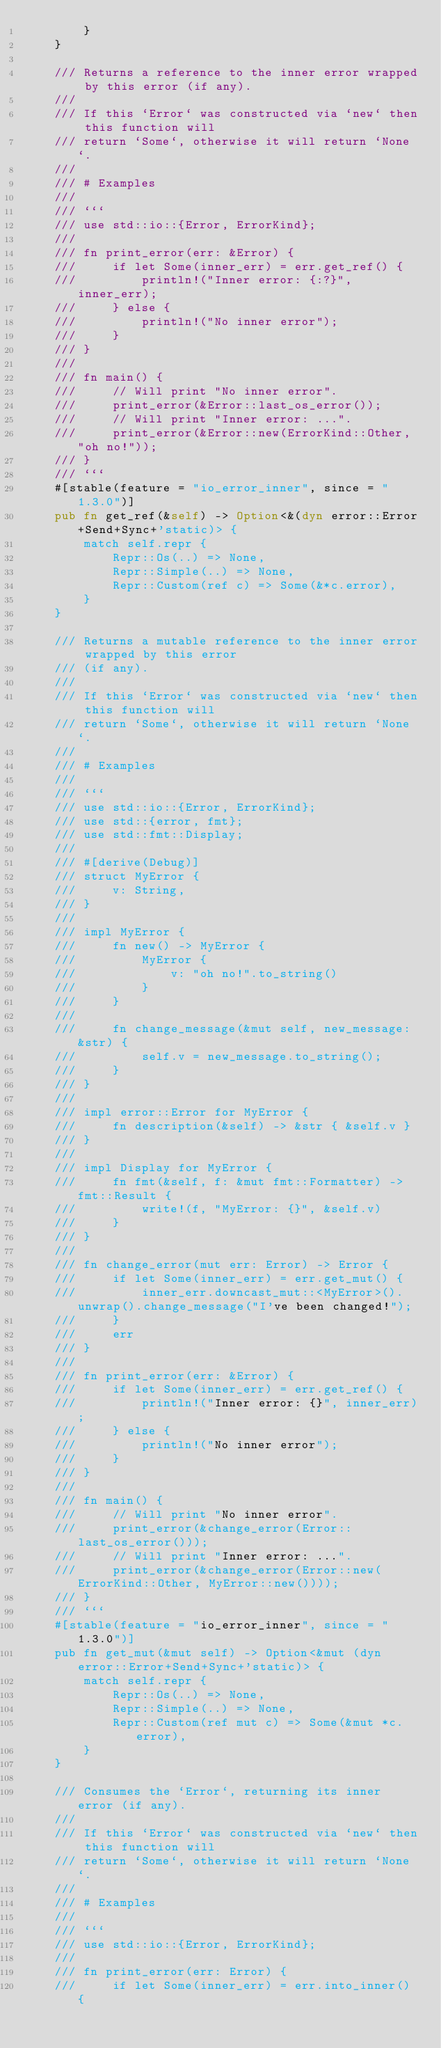<code> <loc_0><loc_0><loc_500><loc_500><_Rust_>        }
    }

    /// Returns a reference to the inner error wrapped by this error (if any).
    ///
    /// If this `Error` was constructed via `new` then this function will
    /// return `Some`, otherwise it will return `None`.
    ///
    /// # Examples
    ///
    /// ```
    /// use std::io::{Error, ErrorKind};
    ///
    /// fn print_error(err: &Error) {
    ///     if let Some(inner_err) = err.get_ref() {
    ///         println!("Inner error: {:?}", inner_err);
    ///     } else {
    ///         println!("No inner error");
    ///     }
    /// }
    ///
    /// fn main() {
    ///     // Will print "No inner error".
    ///     print_error(&Error::last_os_error());
    ///     // Will print "Inner error: ...".
    ///     print_error(&Error::new(ErrorKind::Other, "oh no!"));
    /// }
    /// ```
    #[stable(feature = "io_error_inner", since = "1.3.0")]
    pub fn get_ref(&self) -> Option<&(dyn error::Error+Send+Sync+'static)> {
        match self.repr {
            Repr::Os(..) => None,
            Repr::Simple(..) => None,
            Repr::Custom(ref c) => Some(&*c.error),
        }
    }

    /// Returns a mutable reference to the inner error wrapped by this error
    /// (if any).
    ///
    /// If this `Error` was constructed via `new` then this function will
    /// return `Some`, otherwise it will return `None`.
    ///
    /// # Examples
    ///
    /// ```
    /// use std::io::{Error, ErrorKind};
    /// use std::{error, fmt};
    /// use std::fmt::Display;
    ///
    /// #[derive(Debug)]
    /// struct MyError {
    ///     v: String,
    /// }
    ///
    /// impl MyError {
    ///     fn new() -> MyError {
    ///         MyError {
    ///             v: "oh no!".to_string()
    ///         }
    ///     }
    ///
    ///     fn change_message(&mut self, new_message: &str) {
    ///         self.v = new_message.to_string();
    ///     }
    /// }
    ///
    /// impl error::Error for MyError {
    ///     fn description(&self) -> &str { &self.v }
    /// }
    ///
    /// impl Display for MyError {
    ///     fn fmt(&self, f: &mut fmt::Formatter) -> fmt::Result {
    ///         write!(f, "MyError: {}", &self.v)
    ///     }
    /// }
    ///
    /// fn change_error(mut err: Error) -> Error {
    ///     if let Some(inner_err) = err.get_mut() {
    ///         inner_err.downcast_mut::<MyError>().unwrap().change_message("I've been changed!");
    ///     }
    ///     err
    /// }
    ///
    /// fn print_error(err: &Error) {
    ///     if let Some(inner_err) = err.get_ref() {
    ///         println!("Inner error: {}", inner_err);
    ///     } else {
    ///         println!("No inner error");
    ///     }
    /// }
    ///
    /// fn main() {
    ///     // Will print "No inner error".
    ///     print_error(&change_error(Error::last_os_error()));
    ///     // Will print "Inner error: ...".
    ///     print_error(&change_error(Error::new(ErrorKind::Other, MyError::new())));
    /// }
    /// ```
    #[stable(feature = "io_error_inner", since = "1.3.0")]
    pub fn get_mut(&mut self) -> Option<&mut (dyn error::Error+Send+Sync+'static)> {
        match self.repr {
            Repr::Os(..) => None,
            Repr::Simple(..) => None,
            Repr::Custom(ref mut c) => Some(&mut *c.error),
        }
    }

    /// Consumes the `Error`, returning its inner error (if any).
    ///
    /// If this `Error` was constructed via `new` then this function will
    /// return `Some`, otherwise it will return `None`.
    ///
    /// # Examples
    ///
    /// ```
    /// use std::io::{Error, ErrorKind};
    ///
    /// fn print_error(err: Error) {
    ///     if let Some(inner_err) = err.into_inner() {</code> 